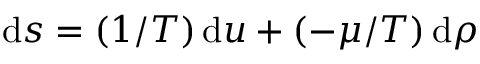Convert formula to latex. <formula><loc_0><loc_0><loc_500><loc_500>d s = ( 1 / T ) \, d u + ( - \mu / T ) \, d \rho</formula> 